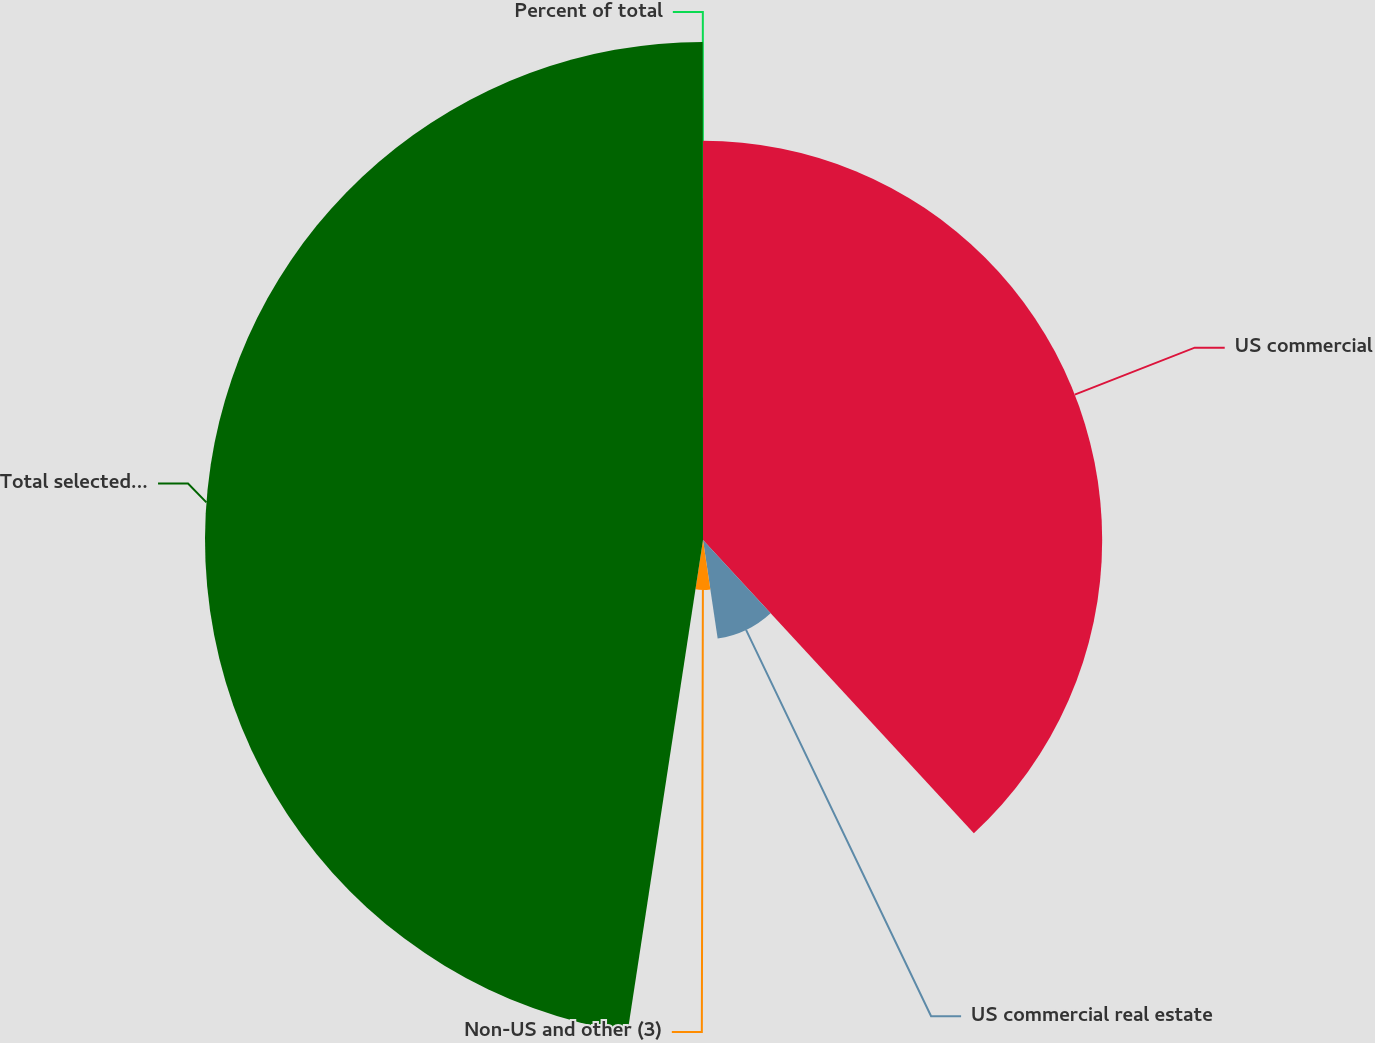Convert chart to OTSL. <chart><loc_0><loc_0><loc_500><loc_500><pie_chart><fcel>US commercial<fcel>US commercial real estate<fcel>Non-US and other (3)<fcel>Total selected loans<fcel>Percent of total<nl><fcel>38.13%<fcel>9.52%<fcel>4.77%<fcel>47.57%<fcel>0.01%<nl></chart> 